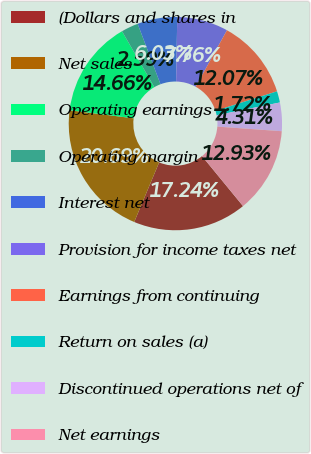<chart> <loc_0><loc_0><loc_500><loc_500><pie_chart><fcel>(Dollars and shares in<fcel>Net sales<fcel>Operating earnings<fcel>Operating margin<fcel>Interest net<fcel>Provision for income taxes net<fcel>Earnings from continuing<fcel>Return on sales (a)<fcel>Discontinued operations net of<fcel>Net earnings<nl><fcel>17.24%<fcel>20.69%<fcel>14.66%<fcel>2.59%<fcel>6.03%<fcel>7.76%<fcel>12.07%<fcel>1.72%<fcel>4.31%<fcel>12.93%<nl></chart> 